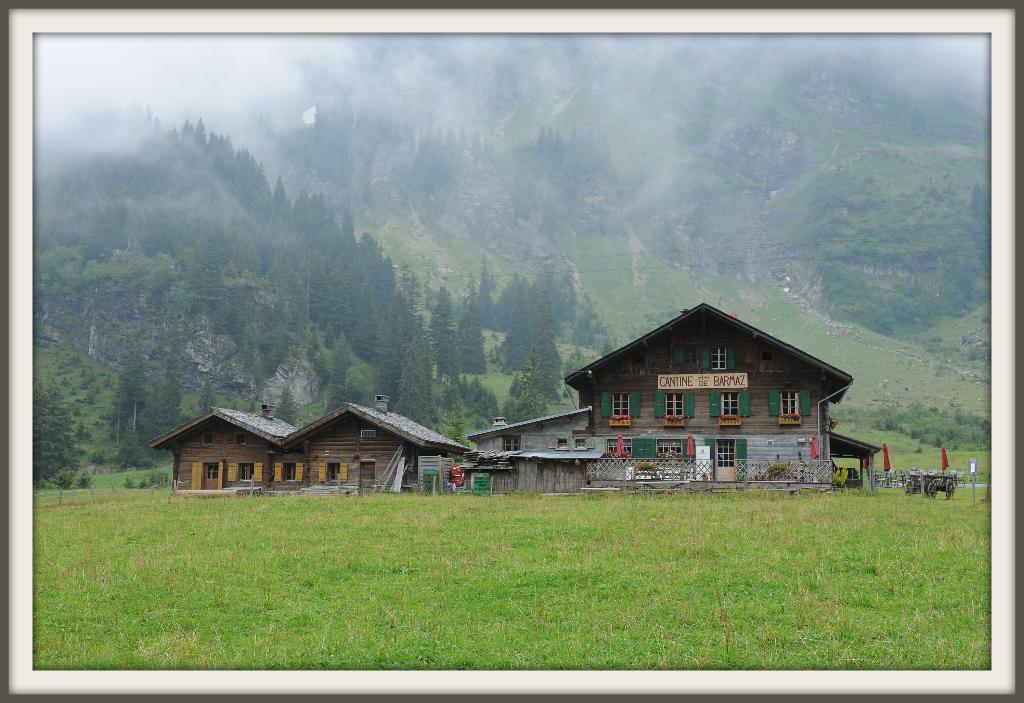Could you give a brief overview of what you see in this image? In this picture I can see there is a building here and there is grass on the floor and in the backdrop there are mountains and they are covered with trees. 